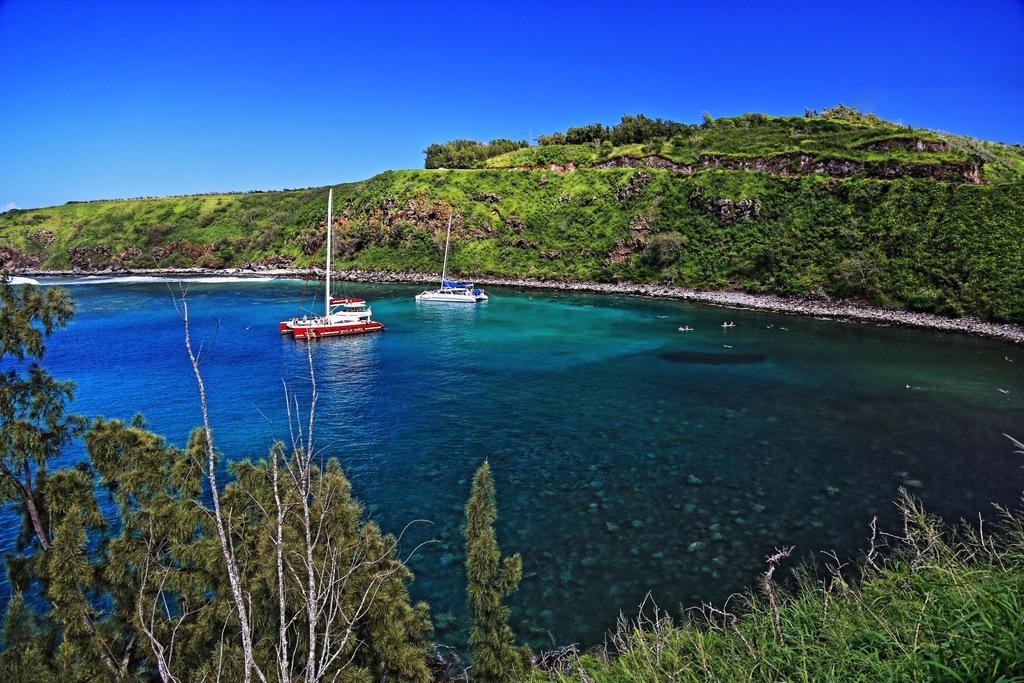What type of vehicles can be seen in the image? There are boats in the water in the image. What type of natural vegetation is visible in the background of the image? There are trees visible in the background of the image. Where is the ice sculpture located in the image? There is no ice sculpture present in the image. What type of animal can be seen grazing near the boats in the image? There are no animals visible in the image. 